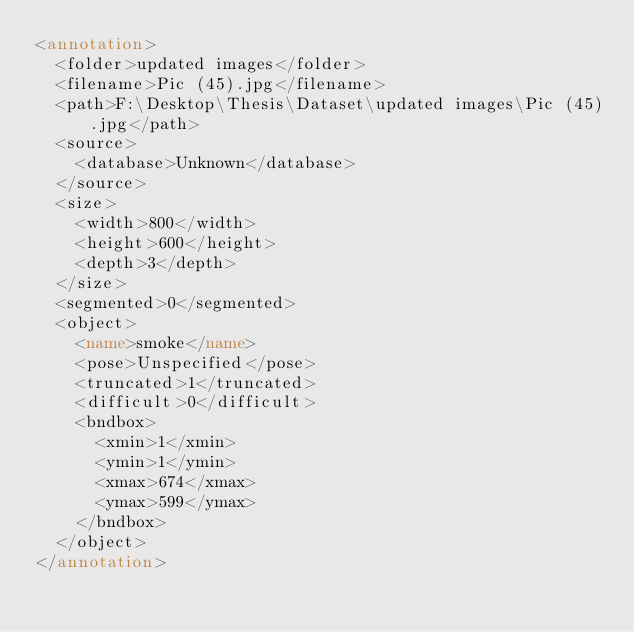<code> <loc_0><loc_0><loc_500><loc_500><_XML_><annotation>
	<folder>updated images</folder>
	<filename>Pic (45).jpg</filename>
	<path>F:\Desktop\Thesis\Dataset\updated images\Pic (45).jpg</path>
	<source>
		<database>Unknown</database>
	</source>
	<size>
		<width>800</width>
		<height>600</height>
		<depth>3</depth>
	</size>
	<segmented>0</segmented>
	<object>
		<name>smoke</name>
		<pose>Unspecified</pose>
		<truncated>1</truncated>
		<difficult>0</difficult>
		<bndbox>
			<xmin>1</xmin>
			<ymin>1</ymin>
			<xmax>674</xmax>
			<ymax>599</ymax>
		</bndbox>
	</object>
</annotation>
</code> 